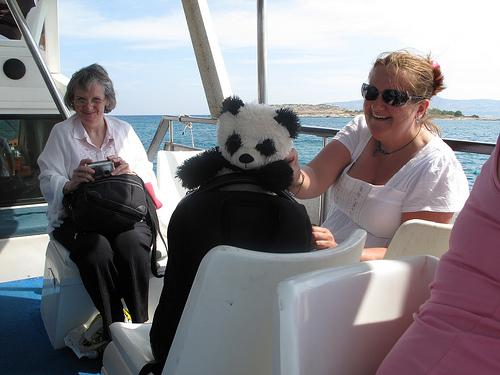Question: who is in the photo?
Choices:
A. Two women.
B. Three men.
C. Two women and a men.
D. Three women.
Answer with the letter. Answer: D Question: where are the people?
Choices:
A. In the car.
B. In the water.
C. On a boat.
D. On the deck.
Answer with the letter. Answer: C Question: what color is the woman in the corner's shirt?
Choices:
A. Pink.
B. Yellow.
C. White.
D. Green.
Answer with the letter. Answer: A 